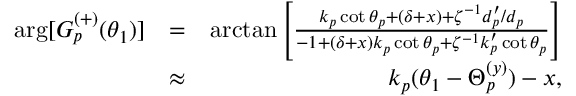<formula> <loc_0><loc_0><loc_500><loc_500>\begin{array} { r l r } { \arg [ G _ { p } ^ { ( + ) } ( \theta _ { 1 } ) ] } & { = } & { \arctan \left [ \frac { k _ { p } \cot \theta _ { p } + \left ( \delta + x \right ) + \zeta ^ { - 1 } d _ { p } ^ { \prime } / d _ { p } } { - 1 + \left ( \delta + x \right ) k _ { p } \cot \theta _ { p } + \zeta ^ { - 1 } k _ { p } ^ { \prime } \cot \theta _ { p } } \right ] } \\ & { \approx } & { k _ { p } ( \theta _ { 1 } - \Theta _ { p } ^ { ( y ) } ) - x , } \end{array}</formula> 